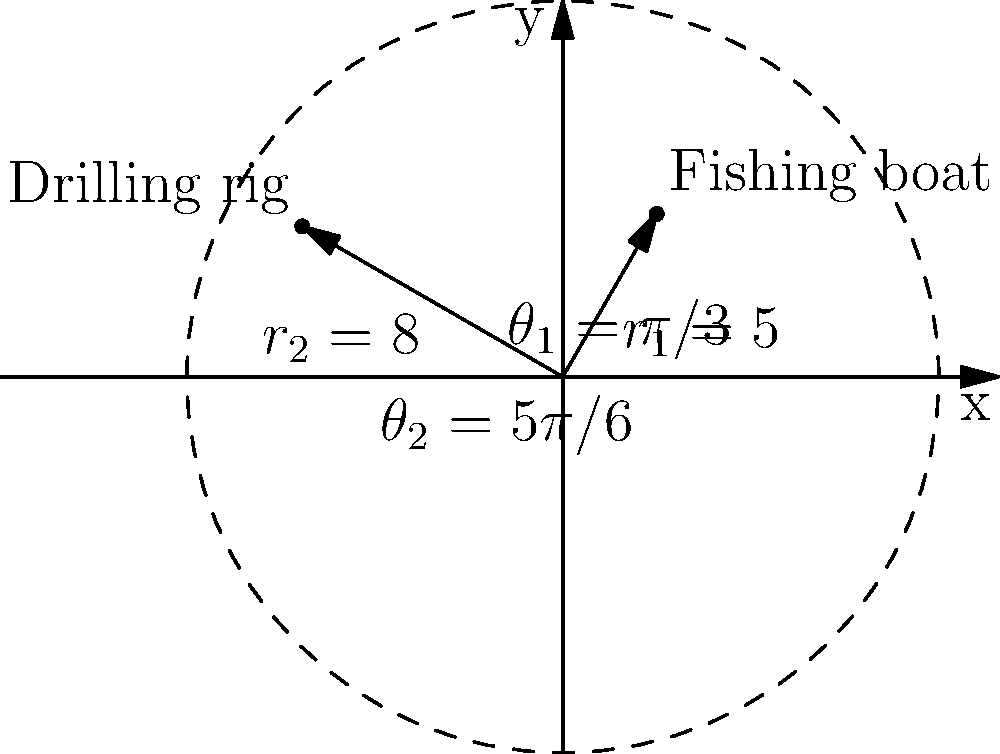A fishing boat is located at polar coordinates $(5, \pi/3)$ and the nearest offshore drilling rig is at $(8, 5\pi/6)$. Calculate the distance between the fishing boat and the drilling rig to the nearest tenth of a unit. To find the distance between two points in polar coordinates, we can use the following steps:

1) Convert the polar coordinates to Cartesian coordinates:
   For the fishing boat $(r_1, \theta_1) = (5, \pi/3)$:
   $x_1 = r_1 \cos(\theta_1) = 5 \cos(\pi/3) = 2.5$
   $y_1 = r_1 \sin(\theta_1) = 5 \sin(\pi/3) = 4.33$

   For the drilling rig $(r_2, \theta_2) = (8, 5\pi/6)$:
   $x_2 = r_2 \cos(\theta_2) = 8 \cos(5\pi/6) = -6.93$
   $y_2 = r_2 \sin(\theta_2) = 8 \sin(5\pi/6) = 4$

2) Use the distance formula between two points in Cartesian coordinates:
   $d = \sqrt{(x_2-x_1)^2 + (y_2-y_1)^2}$

3) Plug in the values:
   $d = \sqrt{(-6.93-2.5)^2 + (4-4.33)^2}$
   $d = \sqrt{(-9.43)^2 + (-0.33)^2}$
   $d = \sqrt{88.9249 + 0.1089}$
   $d = \sqrt{89.0338}$
   $d \approx 9.4$

Therefore, the distance between the fishing boat and the drilling rig is approximately 9.4 units.
Answer: 9.4 units 